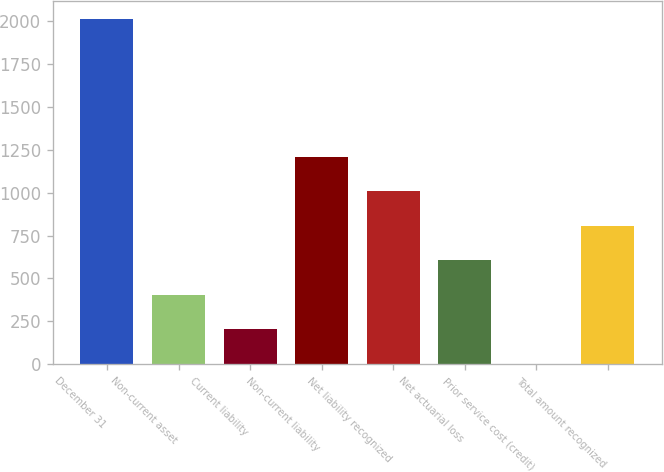Convert chart to OTSL. <chart><loc_0><loc_0><loc_500><loc_500><bar_chart><fcel>December 31<fcel>Non-current asset<fcel>Current liability<fcel>Non-current liability<fcel>Net liability recognized<fcel>Net actuarial loss<fcel>Prior service cost (credit)<fcel>Total amount recognized<nl><fcel>2015<fcel>403.48<fcel>202.04<fcel>1209.24<fcel>1007.8<fcel>604.92<fcel>0.6<fcel>806.36<nl></chart> 